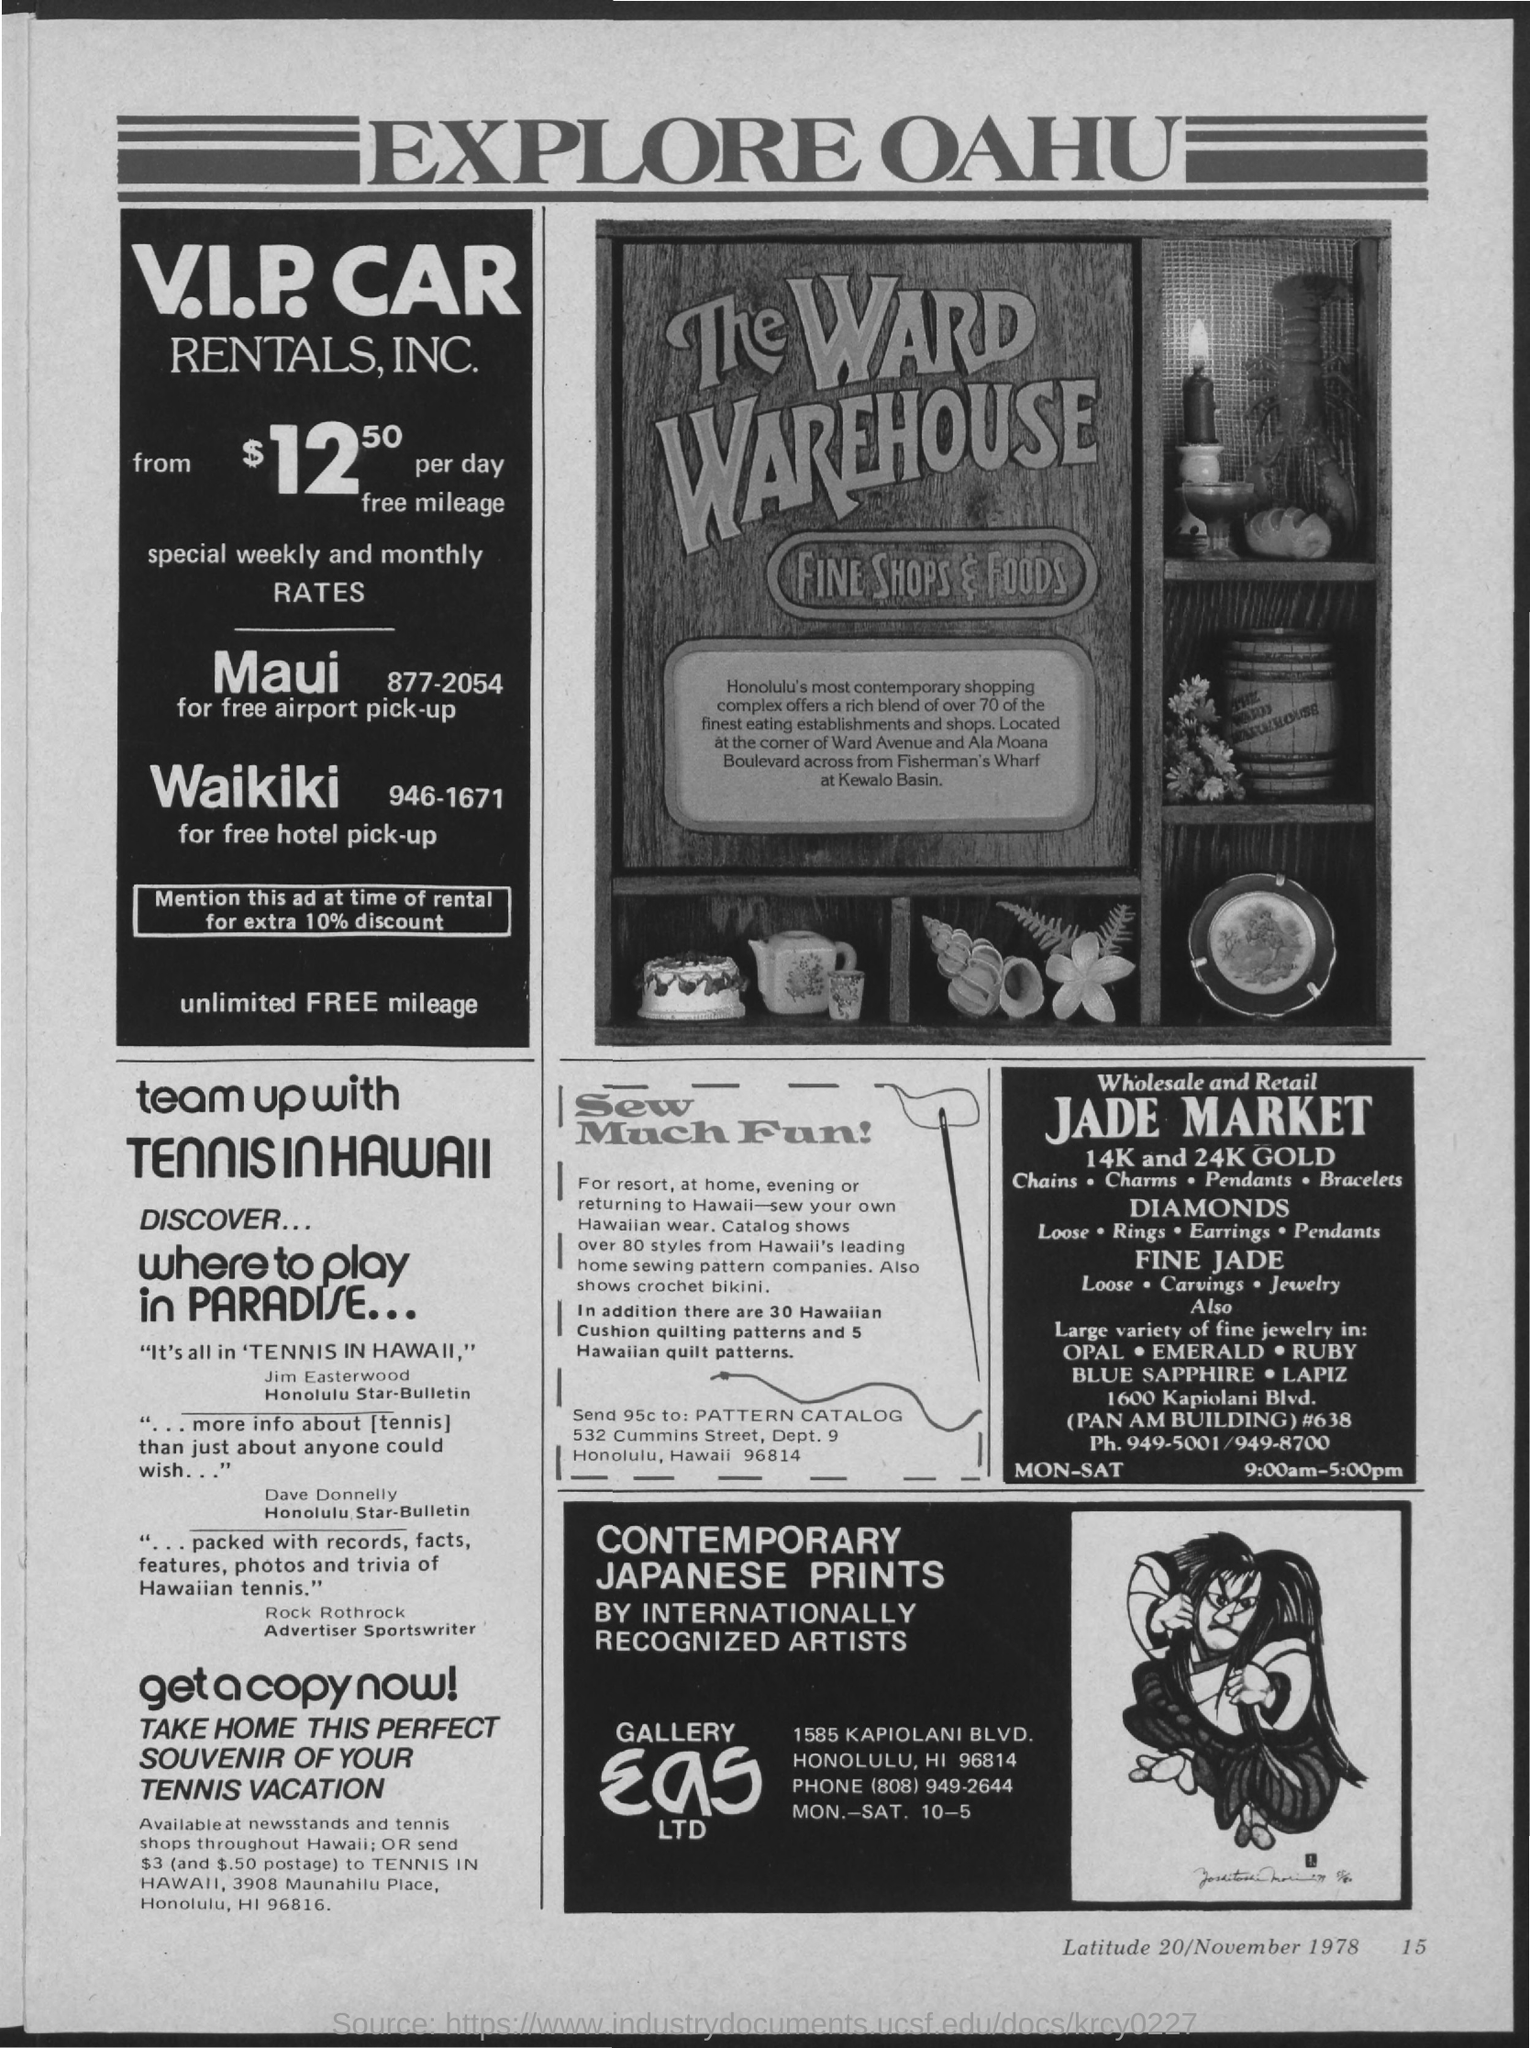Indicate a few pertinent items in this graphic. The heading of the advertisement reads, "Explore Oahu: Discover the Island's Best Attractions. 